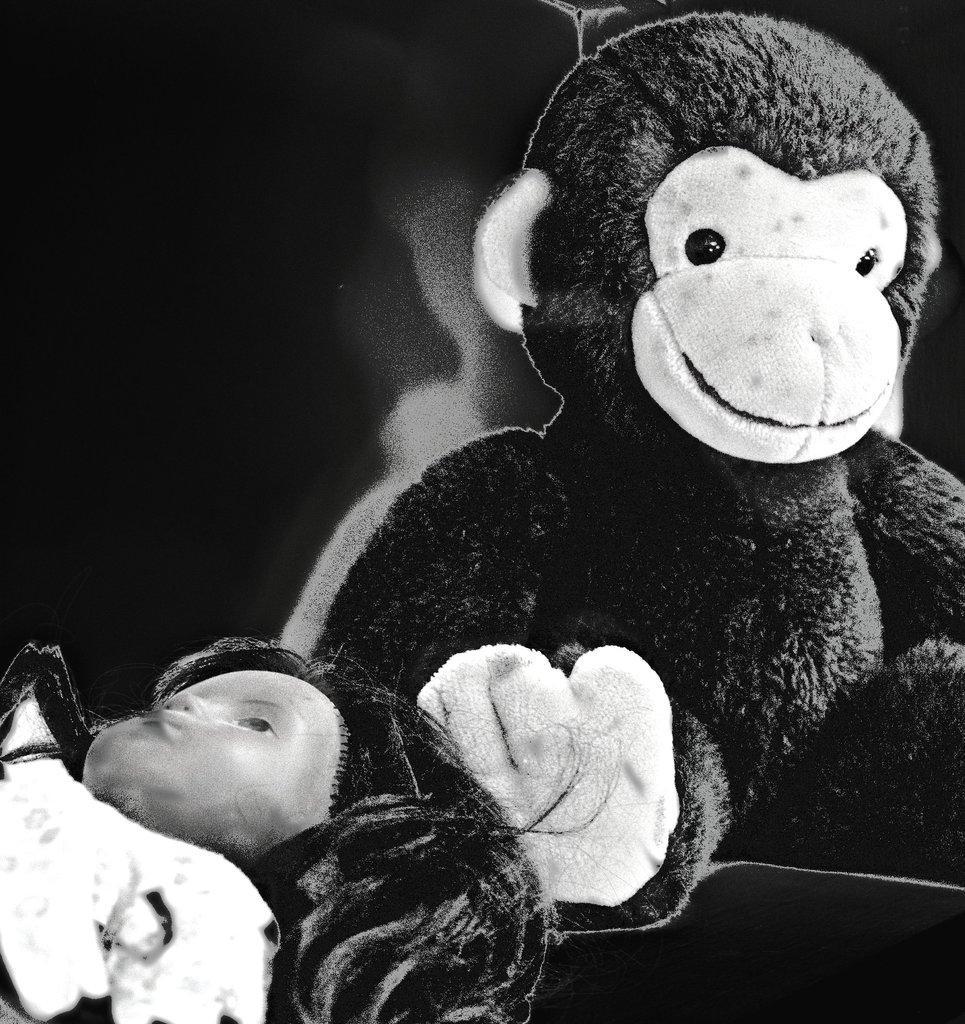Can you describe this image briefly? This image consists of dolls. the background is blurred. 